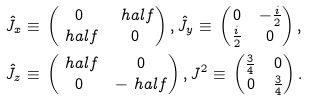<formula> <loc_0><loc_0><loc_500><loc_500>\hat { J } _ { x } & \equiv \, \begin{pmatrix} 0 & \ h a l f \\ \ h a l f & 0 \end{pmatrix} , \hat { J } _ { y } \equiv \, \begin{pmatrix} 0 & - \frac { i } { 2 } \\ \frac { i } { 2 } & 0 \end{pmatrix} , \\ \hat { J } _ { z } & \equiv \, \begin{pmatrix} \ h a l f & 0 \\ 0 & - \ h a l f \end{pmatrix} , J ^ { 2 } \equiv \, \begin{pmatrix} \frac { 3 } { 4 } & 0 \\ 0 & \frac { 3 } { 4 } \end{pmatrix} .</formula> 